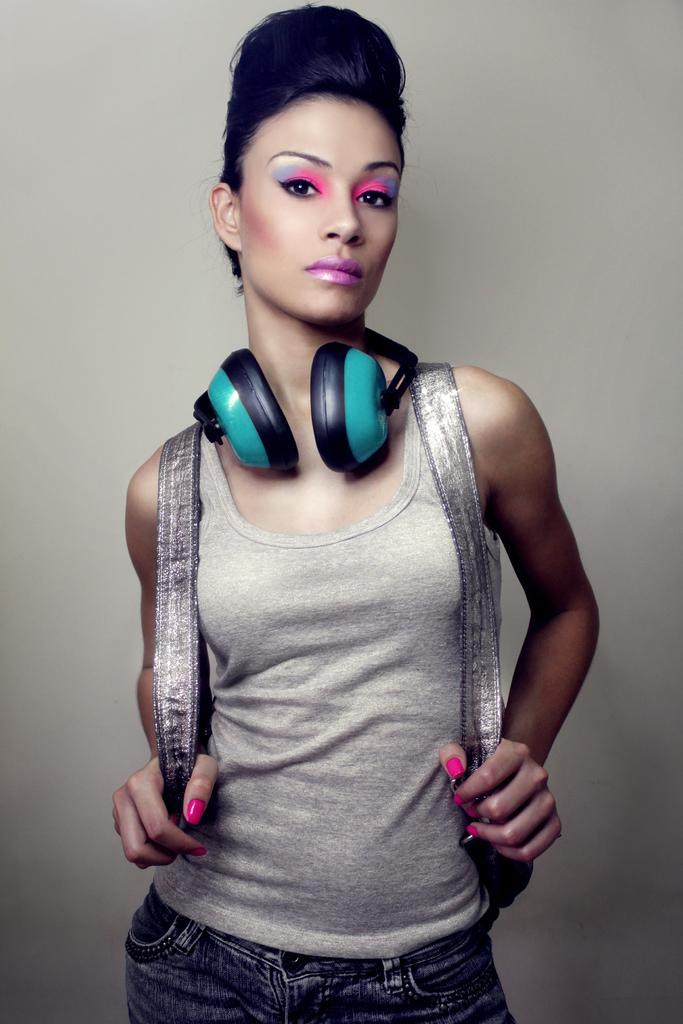Describe this image in one or two sentences. In this image we can see a woman standing and wearing a bag and we can see headphones around her neck and it looks like she is posing for a photo. 